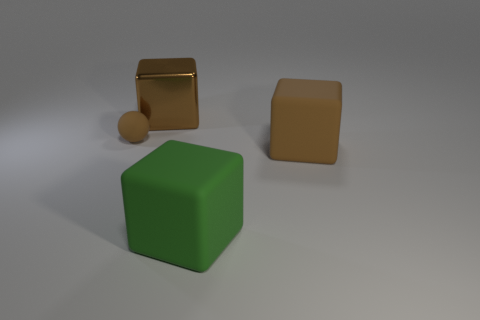Is there anything else that has the same shape as the small brown rubber thing?
Your answer should be very brief. No. Are there any other things that have the same size as the brown rubber sphere?
Offer a terse response. No. Are there any brown rubber cubes to the right of the green cube?
Provide a succinct answer. Yes. There is a big green rubber object; does it have the same shape as the large brown object that is to the right of the brown metal cube?
Provide a succinct answer. Yes. How many objects are brown things that are behind the tiny ball or brown metal things?
Your answer should be very brief. 1. Is there anything else that is the same material as the tiny brown ball?
Your answer should be compact. Yes. How many brown things are behind the small object and in front of the brown matte sphere?
Provide a short and direct response. 0. How many things are brown matte things that are to the right of the large green rubber cube or brown rubber things in front of the tiny rubber thing?
Your response must be concise. 1. What number of other objects are there of the same shape as the big green rubber object?
Your answer should be very brief. 2. Does the object that is on the left side of the big metallic cube have the same color as the large metal thing?
Your answer should be very brief. Yes. 